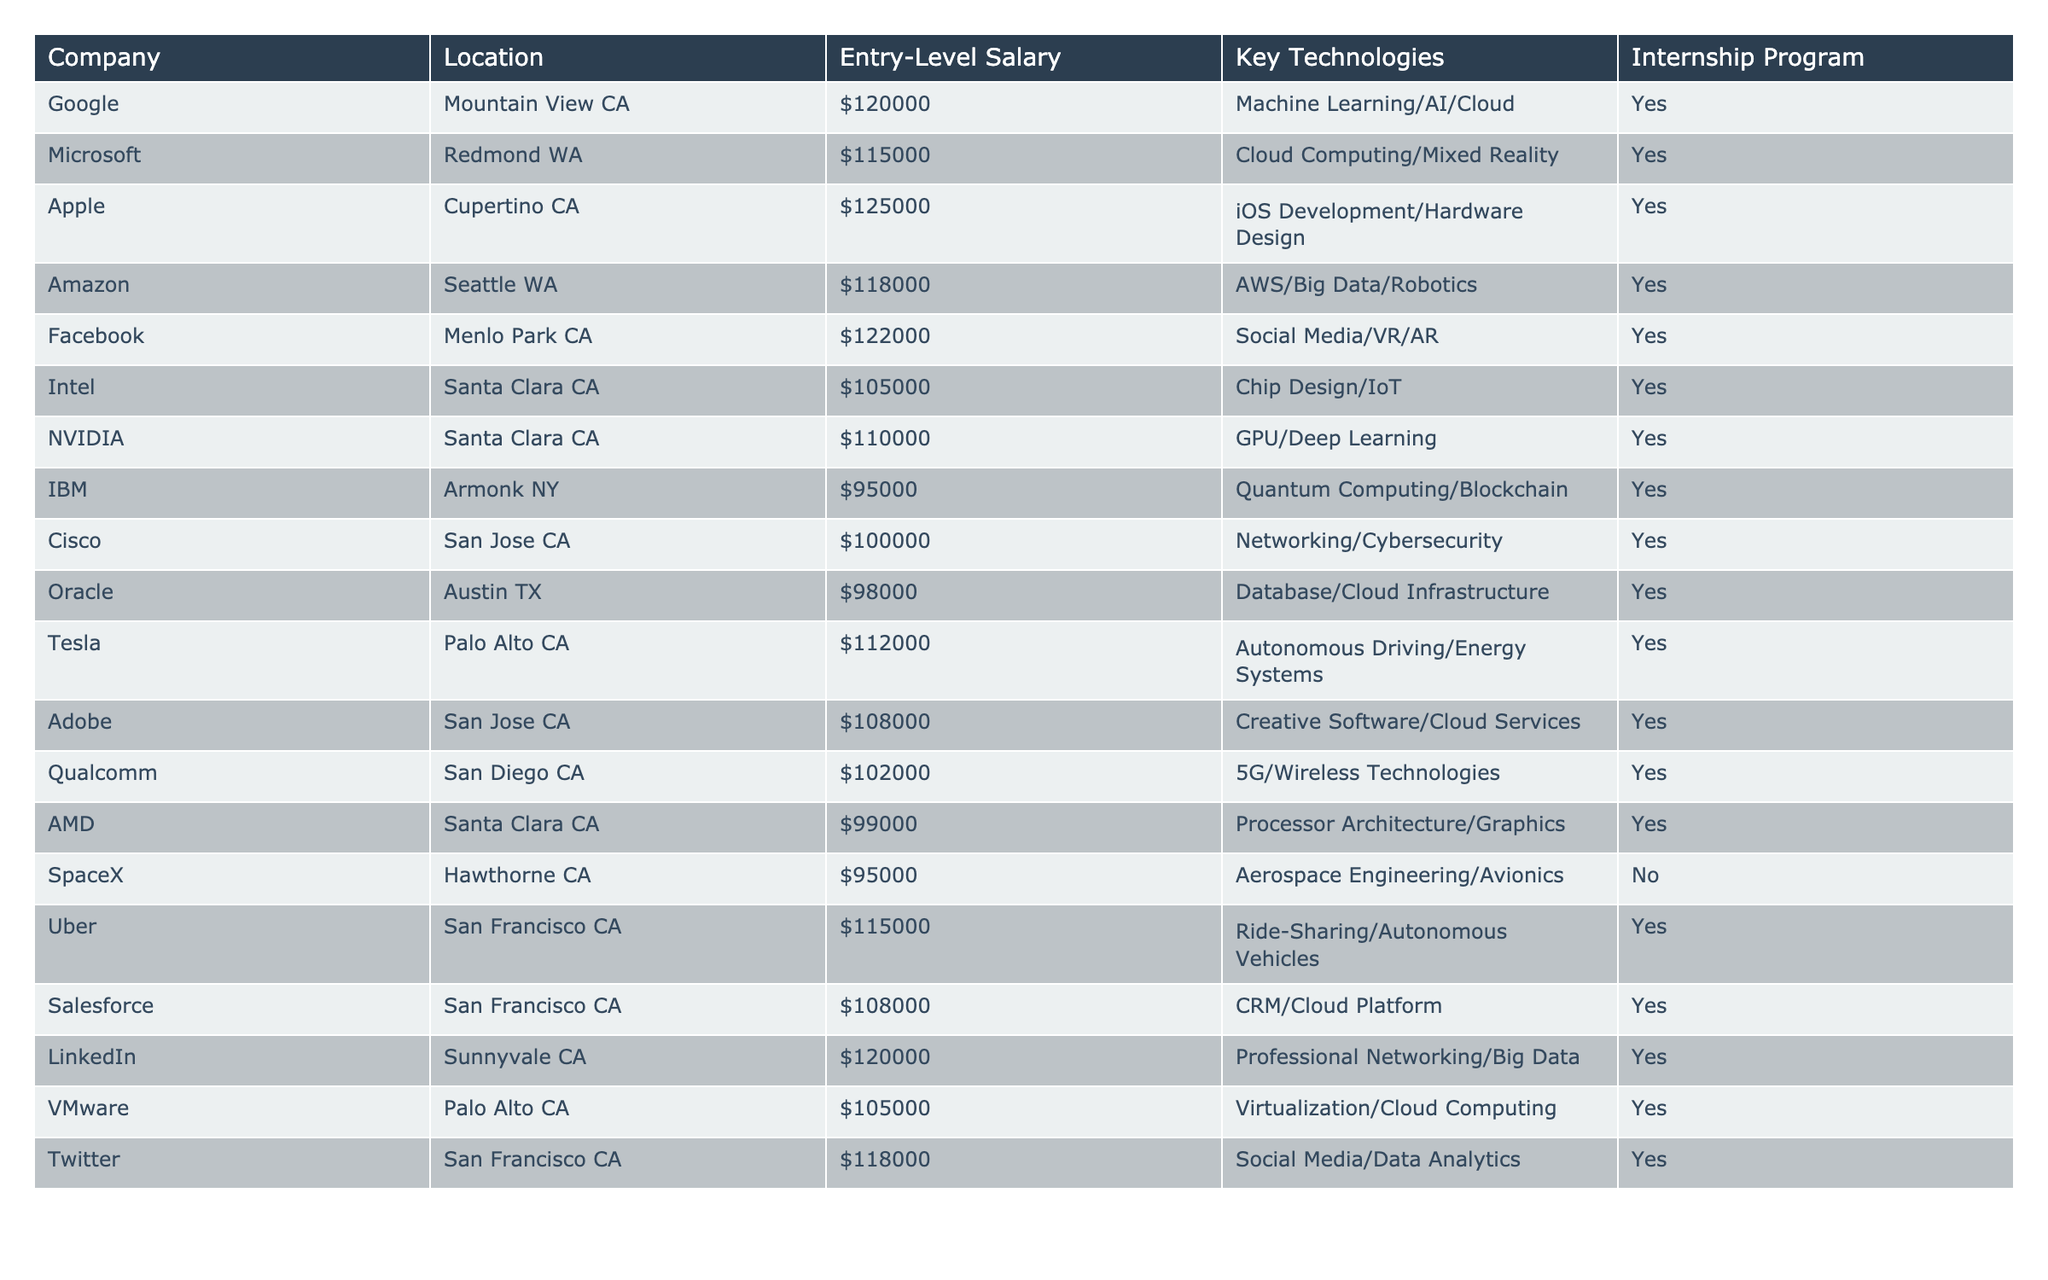What is the highest entry-level salary listed in the table? The entry-level salaries for the companies are ($120000, $115000, $125000, $118000, etc.). The highest salary among these values is $125000, which belongs to Apple.
Answer: $125000 Which company offers the lowest entry-level salary? The entry-level salaries in the table range from $95000 to $125000. The lowest salary listed is $95000, which is offered by both IBM and SpaceX.
Answer: $95000 How many companies have internship programs? Upon reviewing the table, all listed companies except SpaceX have an internship program. Since there are a total of 20 companies and only 1 does not offer an internship, 19 companies have internship programs.
Answer: 19 What is the average entry-level salary offered by the companies in California? First, identify the companies located in California and their salaries: Google ($120000), Apple ($125000), Facebook ($122000), Intel ($105000), NVIDIA ($110000), Tesla ($112000), Cisco ($100000), Adobe ($108000), Qualcomm ($102000), VMare ($105000), Uber ($115000), Salesforce ($108000), LinkedIn ($120000), and Twitter ($118000). The total salary is $120000 + $125000 + $122000 + $105000 + $110000 + $112000 + $100000 + $108000 + $102000 + $105000 + $115000 + $108000 + $120000 + $118000 = $1452000. Since there are 14 companies, the average salary is $1452000 / 14 ≈ $103714.
Answer: Approximately $103714 Is there a company that offers a salary higher than $120000 that is not located in California? Checking the table reveals that the companies offering salaries above $120000 are Apple ($125000), Facebook ($122000), and LinkedIn ($120000). All these companies are located in California. Therefore, no companies outside of California offer salaries above $120000.
Answer: No What percentage of companies are located in California? There are a total of 20 companies in the table, and 14 of them are located in California. To find the percentage, use the formula (Number of California Companies / Total Companies) × 100 = (14 / 20) × 100 = 70%.
Answer: 70% Which company has the highest salary in the non-software sector? From the data, the non-software sectors include companies like Intel (Chip Design/IoT), AMD (Processor Architecture/Graphics), and Tesla (Autonomous Driving/Energy Systems). Their respective entry-level salaries are $105000, $99000, and $112000. Therefore, Tesla offers the highest salary ($112000) among these companies.
Answer: $112000 How many companies are focused on cloud technology? The companies listed with cloud technology as a key focus are Google, Microsoft, Amazon, Oracle, and Salesforce. Counting these, there are 5 companies.
Answer: 5 What is the salary difference between the highest and lowest paying companies? The highest salary is $125000 (Apple) and the lowest is $95000 (IBM and SpaceX). The salary difference is calculated as $125000 - $95000 = $30000.
Answer: $30000 